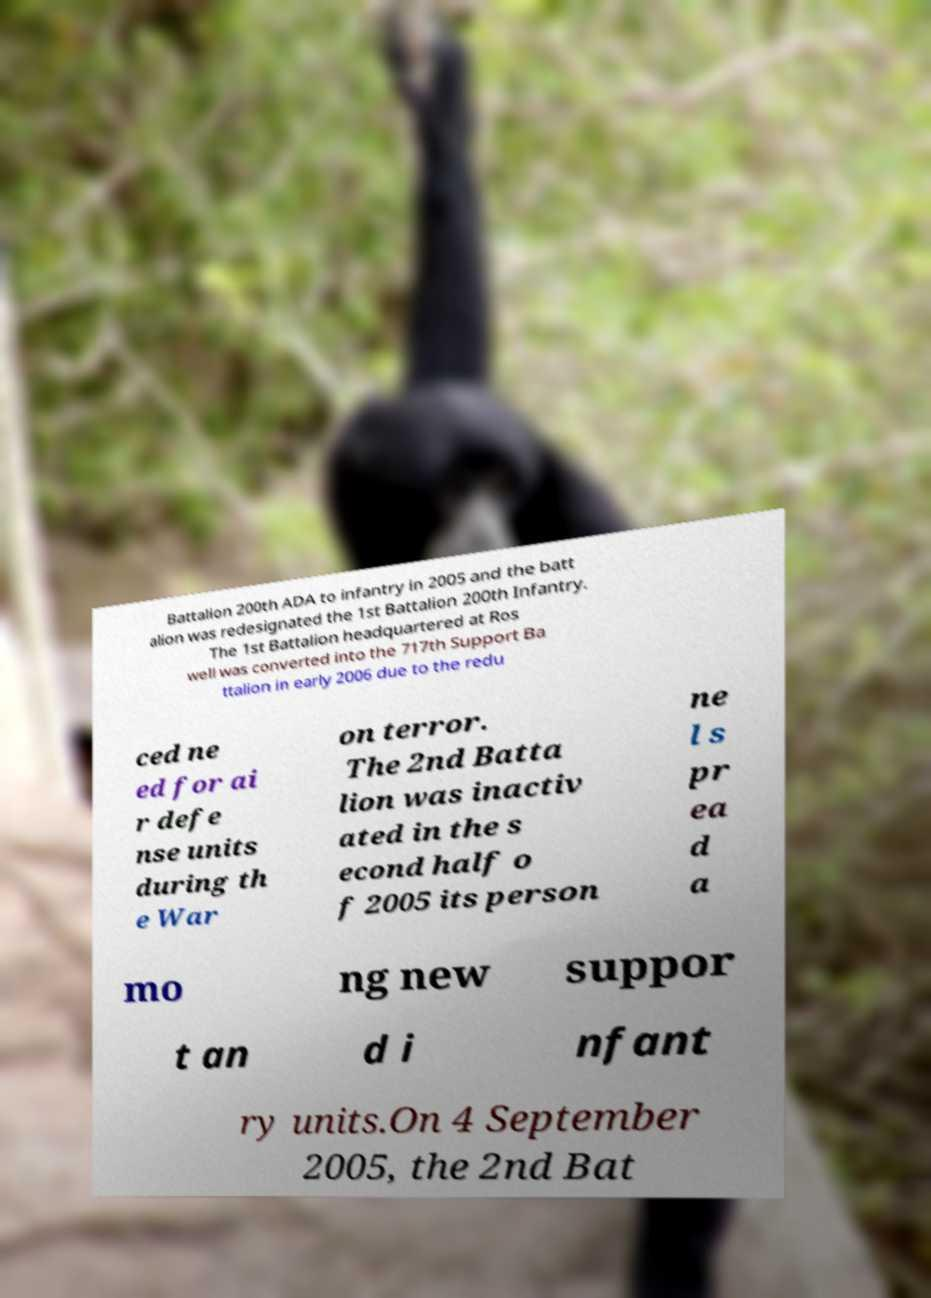There's text embedded in this image that I need extracted. Can you transcribe it verbatim? Battalion 200th ADA to infantry in 2005 and the batt alion was redesignated the 1st Battalion 200th Infantry. The 1st Battalion headquartered at Ros well was converted into the 717th Support Ba ttalion in early 2006 due to the redu ced ne ed for ai r defe nse units during th e War on terror. The 2nd Batta lion was inactiv ated in the s econd half o f 2005 its person ne l s pr ea d a mo ng new suppor t an d i nfant ry units.On 4 September 2005, the 2nd Bat 